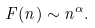Convert formula to latex. <formula><loc_0><loc_0><loc_500><loc_500>F ( n ) \sim n ^ { \alpha } .</formula> 